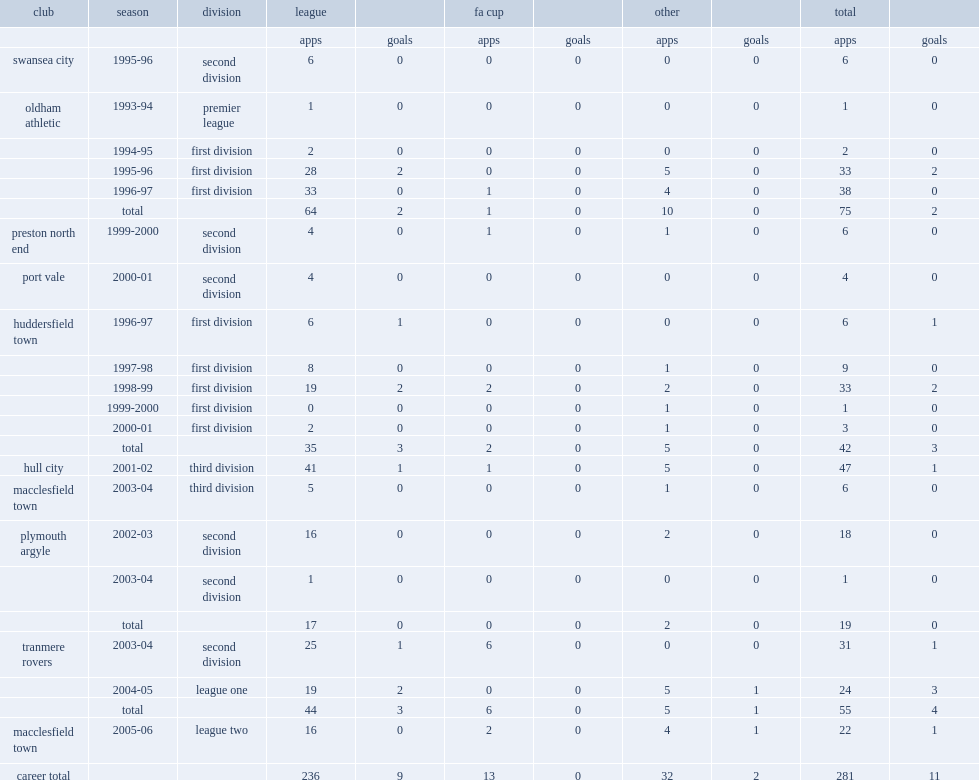What was the number of league appearances made by david beresford in his 12-year career? 236.0. 